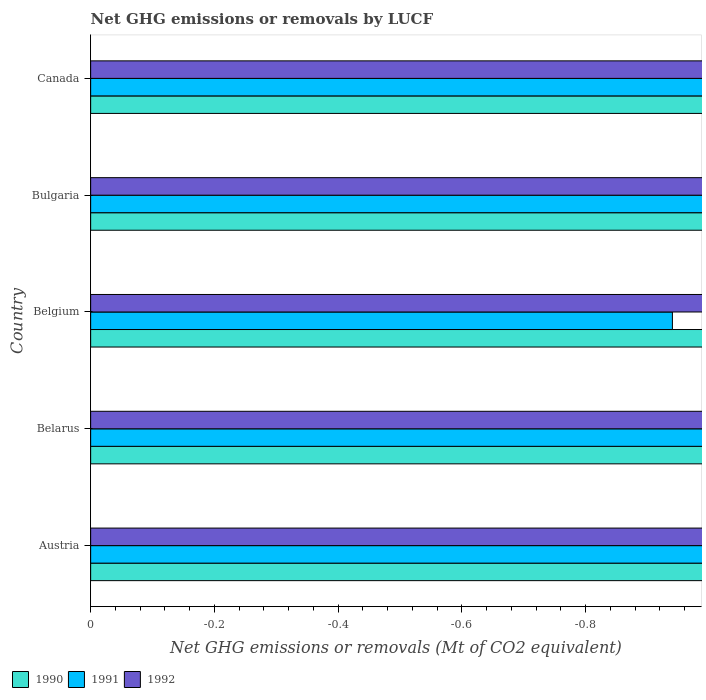Are the number of bars per tick equal to the number of legend labels?
Ensure brevity in your answer.  No. How many bars are there on the 1st tick from the bottom?
Keep it short and to the point. 0. What is the label of the 4th group of bars from the top?
Your answer should be very brief. Belarus. What is the net GHG emissions or removals by LUCF in 1990 in Belgium?
Give a very brief answer. 0. What is the total net GHG emissions or removals by LUCF in 1992 in the graph?
Keep it short and to the point. 0. What is the difference between the net GHG emissions or removals by LUCF in 1991 in Canada and the net GHG emissions or removals by LUCF in 1990 in Belarus?
Your response must be concise. 0. In how many countries, is the net GHG emissions or removals by LUCF in 1991 greater than the average net GHG emissions or removals by LUCF in 1991 taken over all countries?
Keep it short and to the point. 0. How many bars are there?
Offer a terse response. 0. Are all the bars in the graph horizontal?
Your answer should be very brief. Yes. What is the difference between two consecutive major ticks on the X-axis?
Provide a short and direct response. 0.2. Are the values on the major ticks of X-axis written in scientific E-notation?
Your response must be concise. No. Does the graph contain any zero values?
Make the answer very short. Yes. Does the graph contain grids?
Give a very brief answer. No. How many legend labels are there?
Provide a succinct answer. 3. What is the title of the graph?
Your response must be concise. Net GHG emissions or removals by LUCF. Does "2005" appear as one of the legend labels in the graph?
Provide a succinct answer. No. What is the label or title of the X-axis?
Ensure brevity in your answer.  Net GHG emissions or removals (Mt of CO2 equivalent). What is the label or title of the Y-axis?
Offer a terse response. Country. What is the Net GHG emissions or removals (Mt of CO2 equivalent) of 1990 in Austria?
Offer a very short reply. 0. What is the Net GHG emissions or removals (Mt of CO2 equivalent) of 1991 in Austria?
Provide a succinct answer. 0. What is the Net GHG emissions or removals (Mt of CO2 equivalent) in 1992 in Austria?
Offer a very short reply. 0. What is the Net GHG emissions or removals (Mt of CO2 equivalent) of 1990 in Bulgaria?
Offer a very short reply. 0. What is the Net GHG emissions or removals (Mt of CO2 equivalent) of 1991 in Bulgaria?
Give a very brief answer. 0. What is the Net GHG emissions or removals (Mt of CO2 equivalent) of 1990 in Canada?
Give a very brief answer. 0. What is the Net GHG emissions or removals (Mt of CO2 equivalent) in 1992 in Canada?
Give a very brief answer. 0. What is the total Net GHG emissions or removals (Mt of CO2 equivalent) in 1991 in the graph?
Provide a short and direct response. 0. What is the total Net GHG emissions or removals (Mt of CO2 equivalent) of 1992 in the graph?
Your answer should be compact. 0. What is the average Net GHG emissions or removals (Mt of CO2 equivalent) in 1992 per country?
Keep it short and to the point. 0. 